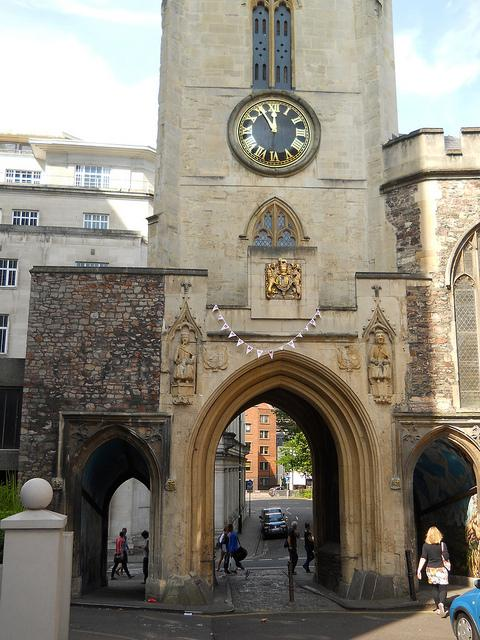What numeral system is used on the clock? Please explain your reasoning. roman. These are roman numerals. 